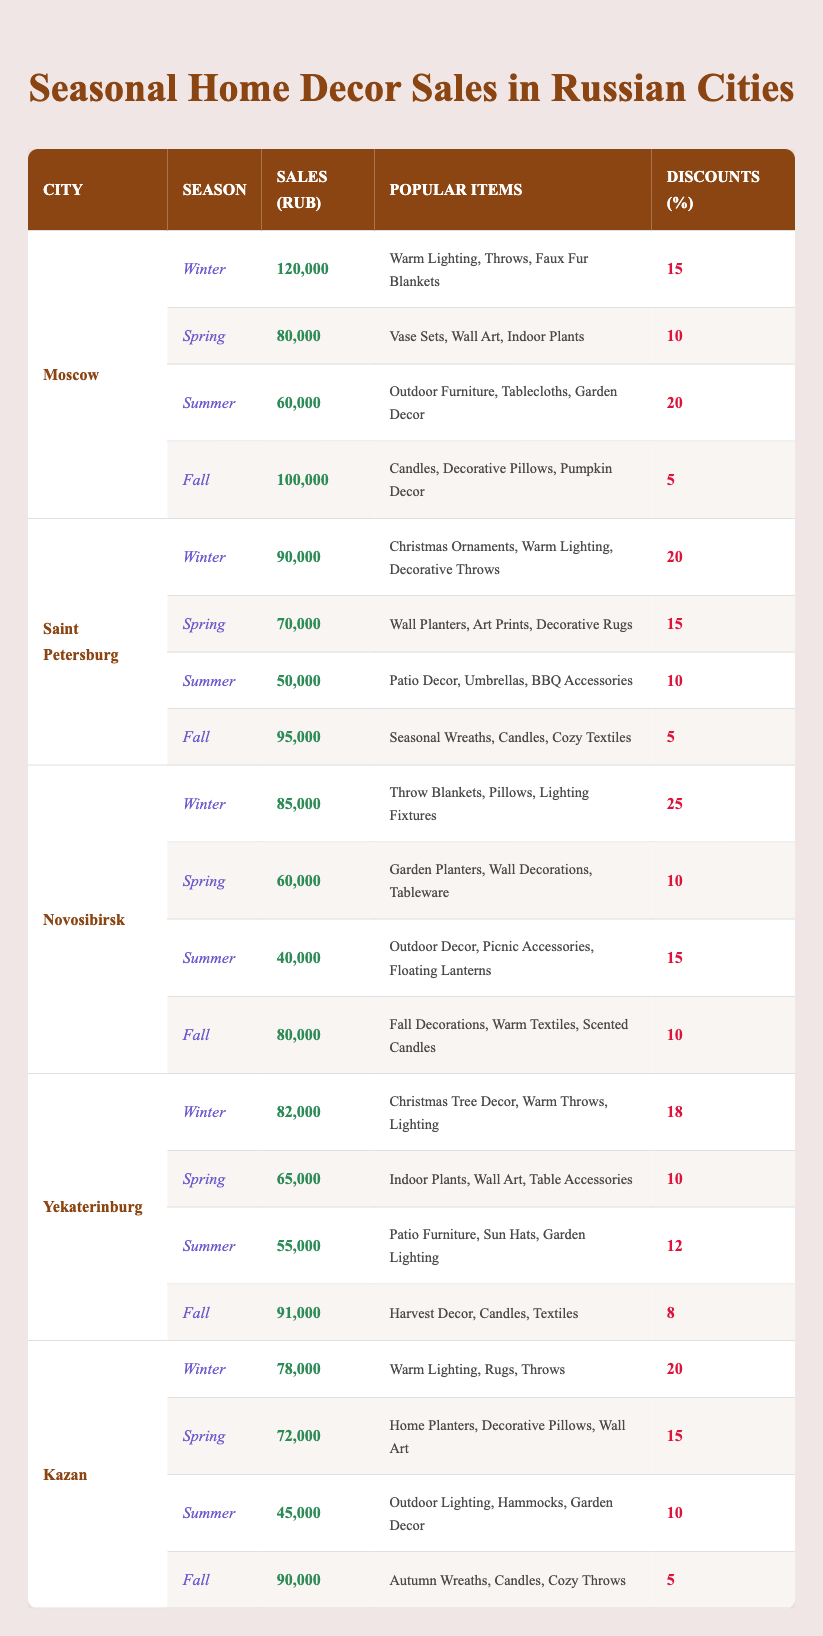What city had the highest sales in Winter? Looking through the table, Moscow has the highest Winter sales of 120,000 RUB compared to Saint Petersburg (90,000), Novosibirsk (85,000), Yekaterinburg (82,000), and Kazan (78,000).
Answer: Moscow Which season had the lowest sales in Novosibirsk? In Novosibirsk, Summer had the lowest sales at 40,000 RUB, when compared to Winter (85,000), Spring (60,000), and Fall (80,000).
Answer: Summer Was the discount for Fall in Moscow higher than that in Kazan? The discount for Fall in Moscow is 5%, while in Kazan it is also 5%. Therefore, the statement is false.
Answer: No What are the popular items in Saint Petersburg for Spring? The popular items in Spring for Saint Petersburg are Wall Planters, Art Prints, and Decorative Rugs.
Answer: Wall Planters, Art Prints, Decorative Rugs How much higher are Winter sales in Moscow compared to Yekaterinburg? Moscow's Winter sales are 120,000 RUB, while Yekaterinburg's are 82,000 RUB. The difference is 120,000 - 82,000 = 38,000 RUB.
Answer: 38,000 RUB What city has the highest average sales across all seasons? First, we calculate the total sales for each city: Moscow: 120,000 + 80,000 + 60,000 + 100,000 = 360,000; Saint Petersburg: 90,000 + 70,000 + 50,000 + 95,000 = 305,000; Novosibirsk: 85,000 + 60,000 + 40,000 + 80,000 = 265,000; Yekaterinburg: 82,000 + 65,000 + 55,000 + 91,000 = 293,000; Kazan: 78,000 + 72,000 + 45,000 + 90,000 = 285,000. Average for Moscow is 360,000 / 4 = 90,000. It has the highest average sales compared to the others.
Answer: Moscow Which seasonal sales had the most popular items in common between Kazan and Yekaterinburg? For Fall in both Kazan and Yekaterinburg, the popular items include Candles, which reflects a commonality in preferences.
Answer: Candles What percentage of sales occurred in Summer for Saint Petersburg? To find the percentage of Summer sales (50,000) from the total sales of the year in Saint Petersburg (305,000), we calculate (50,000 / 305,000) * 100 = 16.39%, approximately.
Answer: 16.39% Which city's Winter sales had the highest discount percentage? Novosibirsk had the highest discount percentage in Winter at 25%, compared to Moscow (15%), Saint Petersburg (20%), Yekaterinburg (18%), and Kazan (20%).
Answer: Novosibirsk Is the average sales in Kazan higher than that in Novosibirsk? The average for Kazan is (78,000 + 72,000 + 45,000 + 90,000) / 4 = 71,250. For Novosibirsk, it is (85,000 + 60,000 + 40,000 + 80,000) / 4 = 66,250. Since 71,250 > 66,250, the statement is true.
Answer: Yes 